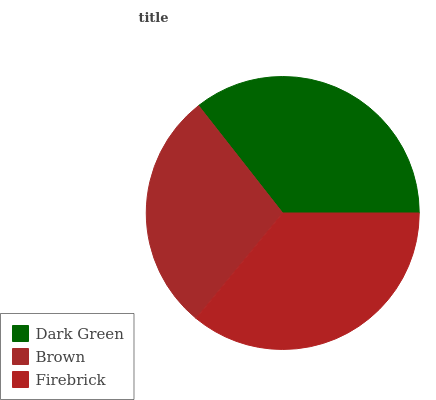Is Brown the minimum?
Answer yes or no. Yes. Is Firebrick the maximum?
Answer yes or no. Yes. Is Firebrick the minimum?
Answer yes or no. No. Is Brown the maximum?
Answer yes or no. No. Is Firebrick greater than Brown?
Answer yes or no. Yes. Is Brown less than Firebrick?
Answer yes or no. Yes. Is Brown greater than Firebrick?
Answer yes or no. No. Is Firebrick less than Brown?
Answer yes or no. No. Is Dark Green the high median?
Answer yes or no. Yes. Is Dark Green the low median?
Answer yes or no. Yes. Is Brown the high median?
Answer yes or no. No. Is Firebrick the low median?
Answer yes or no. No. 